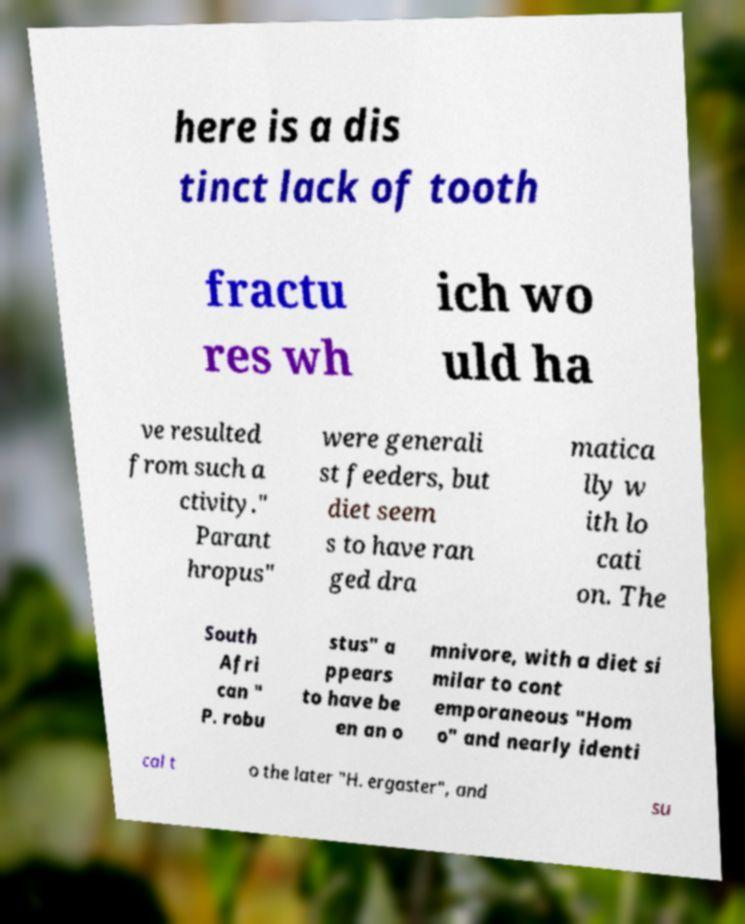There's text embedded in this image that I need extracted. Can you transcribe it verbatim? here is a dis tinct lack of tooth fractu res wh ich wo uld ha ve resulted from such a ctivity." Parant hropus" were generali st feeders, but diet seem s to have ran ged dra matica lly w ith lo cati on. The South Afri can " P. robu stus" a ppears to have be en an o mnivore, with a diet si milar to cont emporaneous "Hom o" and nearly identi cal t o the later "H. ergaster", and su 